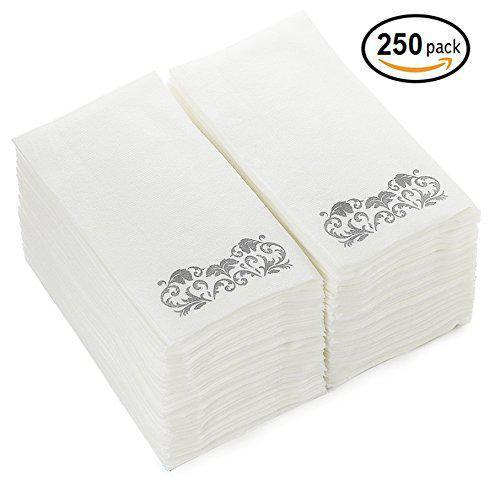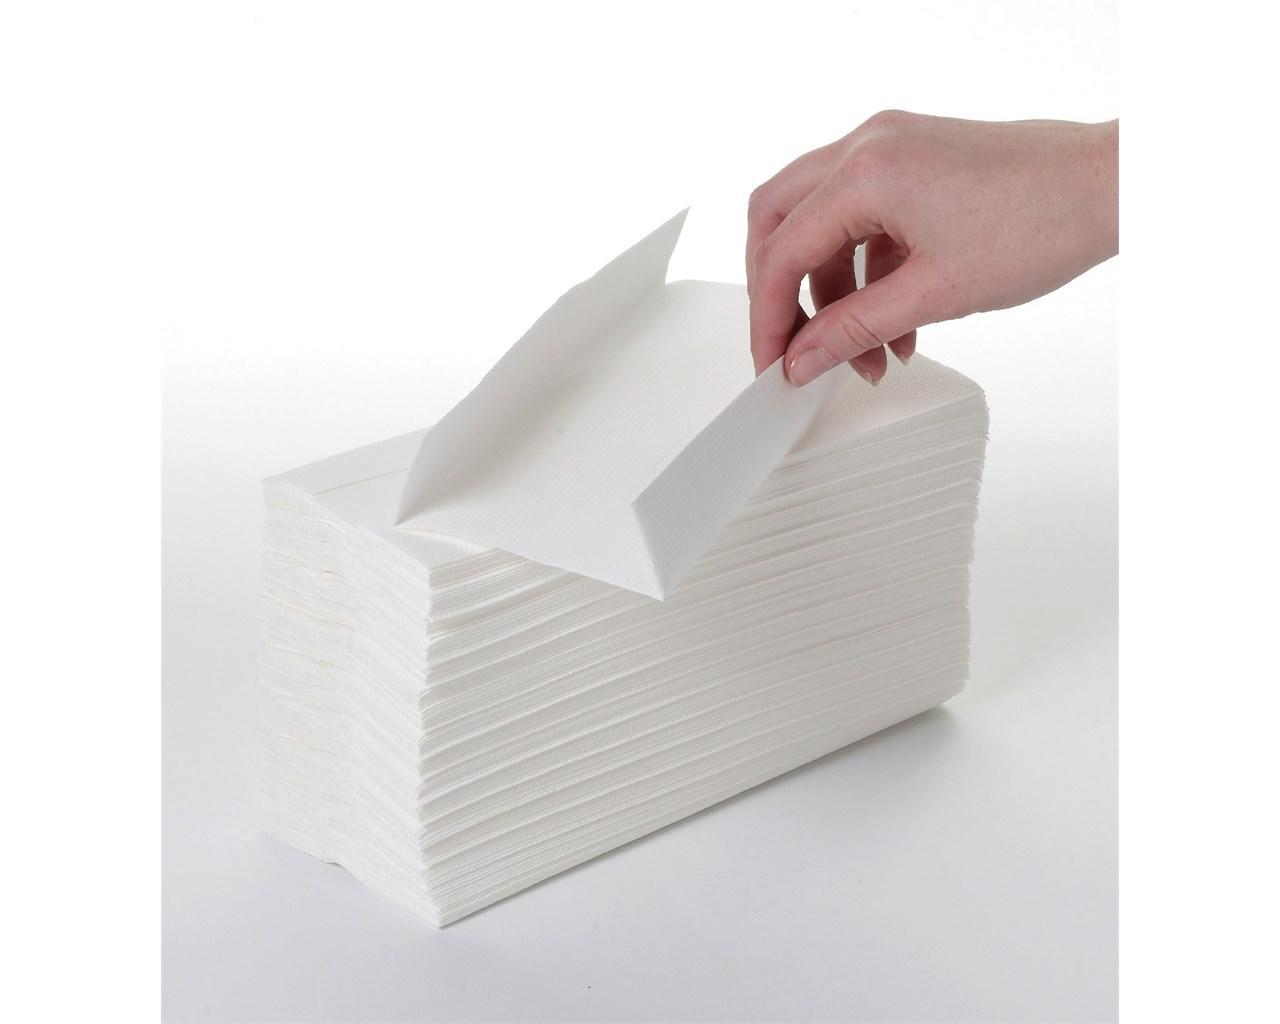The first image is the image on the left, the second image is the image on the right. Analyze the images presented: Is the assertion "The left and right image contains a total of two piles of paper towels that have at least 50 sheet." valid? Answer yes or no. No. 